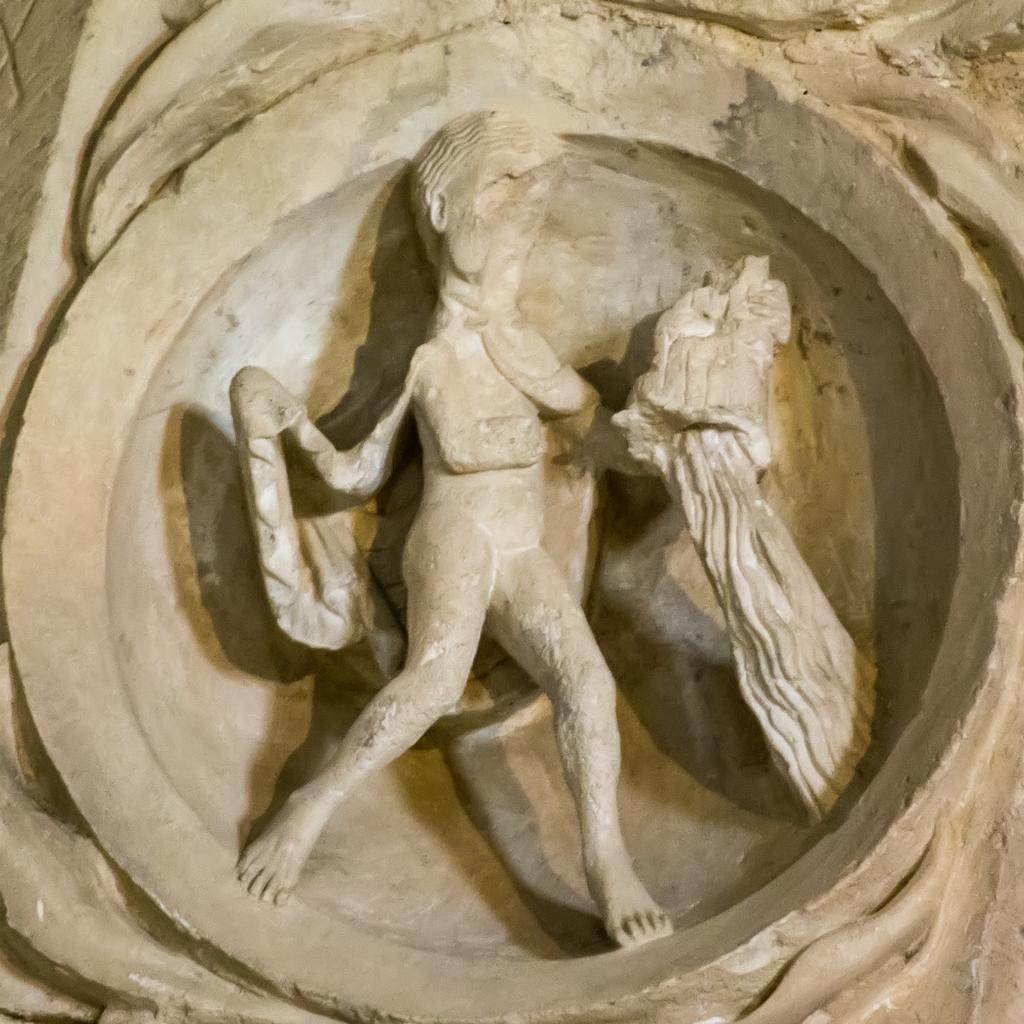Can you describe this image briefly? In this picture I can see a statue in the middle. 